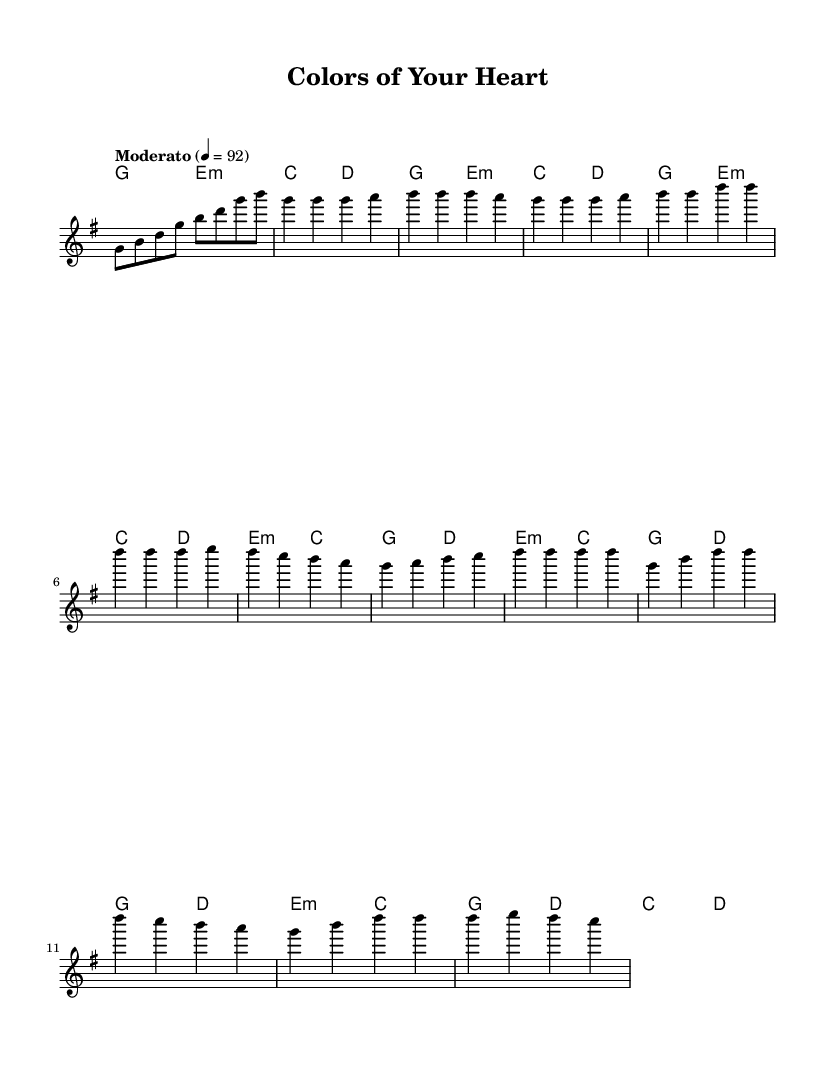What is the key signature of this music? The key signature indicated is G major, as shown by the presence of one sharp (F#).
Answer: G major What is the time signature of this piece? The time signature is marked as 4/4, indicating that there are four beats in each measure and a quarter note receives one beat.
Answer: 4/4 What is the tempo marking for this piece? The tempo marking is "Moderato" with a speed of 92 beats per minute, which suggests a moderate pace for the performance.
Answer: Moderato How many measures are in the chorus section? The chorus consists of four measures, as indicated by the arrangement of notes and rests in that section of the sheet music.
Answer: Four What is the first note of the pre-chorus? The first note of the pre-chorus is D, which can be identified at the beginning of the pre-chorus section of the sheet music.
Answer: D Which word appears at the start of the verse lyrics? The first word of the verse lyrics is "Little," which starts the lyrical narrative of the song.
Answer: Little What emotion does the title "Colors of Your Heart" convey? The title suggests themes of creativity and emotional expression, aligning with the song's encouragement to express oneself through art.
Answer: Creativity 